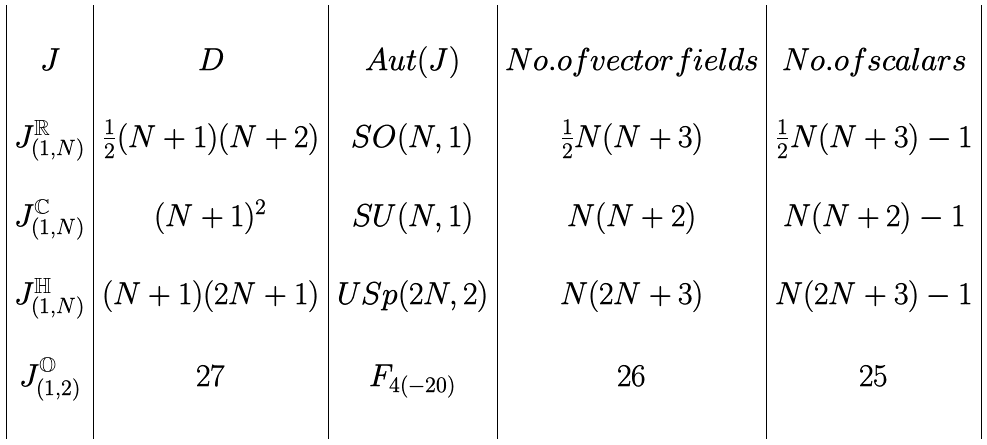Convert formula to latex. <formula><loc_0><loc_0><loc_500><loc_500>\begin{array} { | c | c | c | c | c | } & & & & \\ J & D & A u t ( J ) & N o . o f v e c t o r f i e l d s & N o . o f s c a l a r s \\ & & & & \\ J _ { ( 1 , N ) } ^ { \mathbb { R } } & \frac { 1 } { 2 } ( N + 1 ) ( N + 2 ) & S O ( N , 1 ) & \frac { 1 } { 2 } N ( N + 3 ) & \frac { 1 } { 2 } N ( N + 3 ) - 1 \\ & & & & \\ J _ { ( 1 , N ) } ^ { \mathbb { C } } & ( N + 1 ) ^ { 2 } & S U ( N , 1 ) & N ( N + 2 ) & N ( N + 2 ) - 1 \\ & & & & \\ J _ { ( 1 , N ) } ^ { \mathbb { H } } & ( N + 1 ) ( 2 N + 1 ) & U S p ( 2 N , 2 ) & N ( 2 N + 3 ) & N ( 2 N + 3 ) - 1 \\ & & & & \\ J _ { ( 1 , 2 ) } ^ { \mathbb { O } } & 2 7 & F _ { 4 ( - 2 0 ) } & 2 6 & 2 5 \\ & & & & \\ \end{array}</formula> 